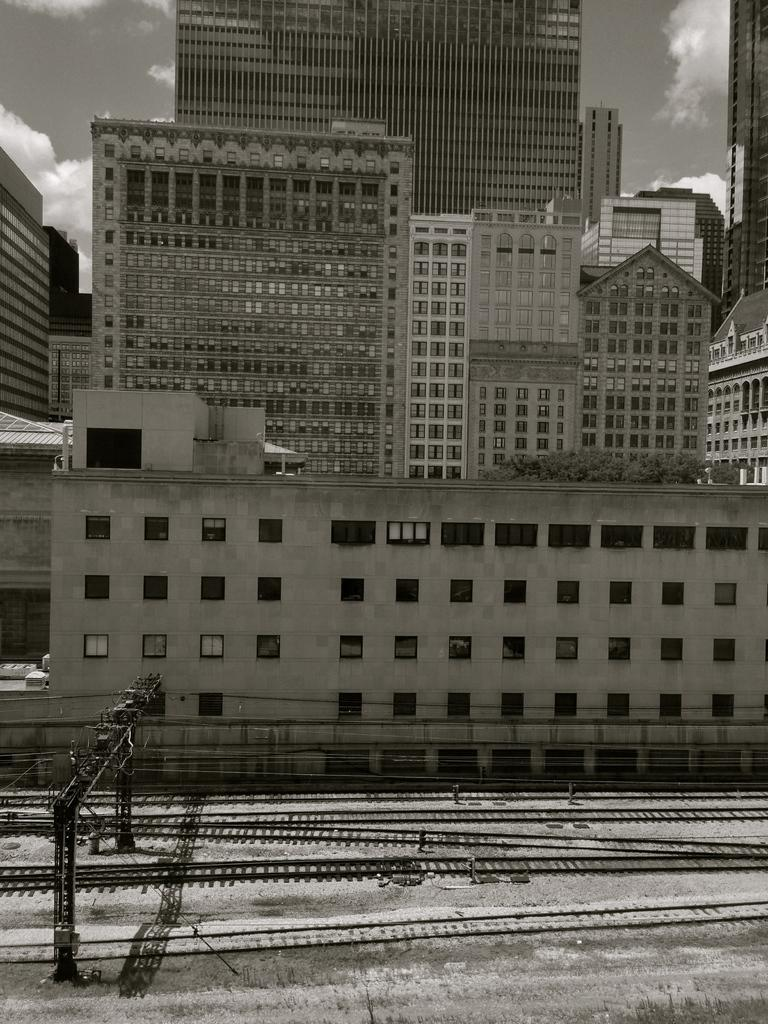What structures are located in the middle of the image? There are buildings in the middle of the image. What is visible in the background of the image? The sky is visible in the image. What can be seen in the sky? Clouds are present in the sky. What is located at the bottom of the image? Railway tracks and cables are at the bottom of the image. What is the ground like in the image? The ground is visible at the bottom of the image. How is the glue being used in the image? There is no glue present in the image. What type of police presence can be seen in the image? There is no police presence in the image. 